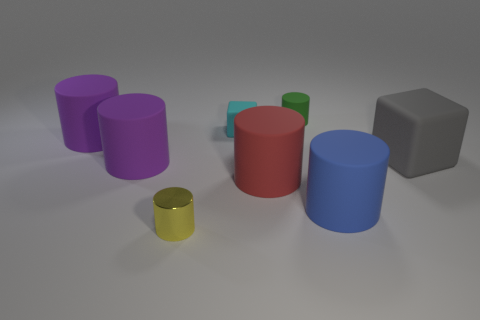There is a large purple object behind the purple thing in front of the big thing behind the gray matte thing; what is its shape?
Provide a short and direct response. Cylinder. There is a shiny object that is the same shape as the green rubber thing; what is its color?
Ensure brevity in your answer.  Yellow. What color is the block that is behind the matte block in front of the tiny cyan block?
Provide a short and direct response. Cyan. What is the size of the red thing that is the same shape as the large blue thing?
Offer a very short reply. Large. How many blue cylinders have the same material as the green cylinder?
Provide a succinct answer. 1. There is a tiny cylinder that is behind the metal cylinder; what number of small yellow things are right of it?
Make the answer very short. 0. Are there any tiny cyan matte cubes on the left side of the small green matte object?
Your answer should be compact. Yes. Do the large thing behind the large matte block and the green object have the same shape?
Keep it short and to the point. Yes. What number of cubes have the same color as the tiny shiny object?
Keep it short and to the point. 0. The purple matte object to the right of the purple cylinder behind the large gray object is what shape?
Ensure brevity in your answer.  Cylinder. 